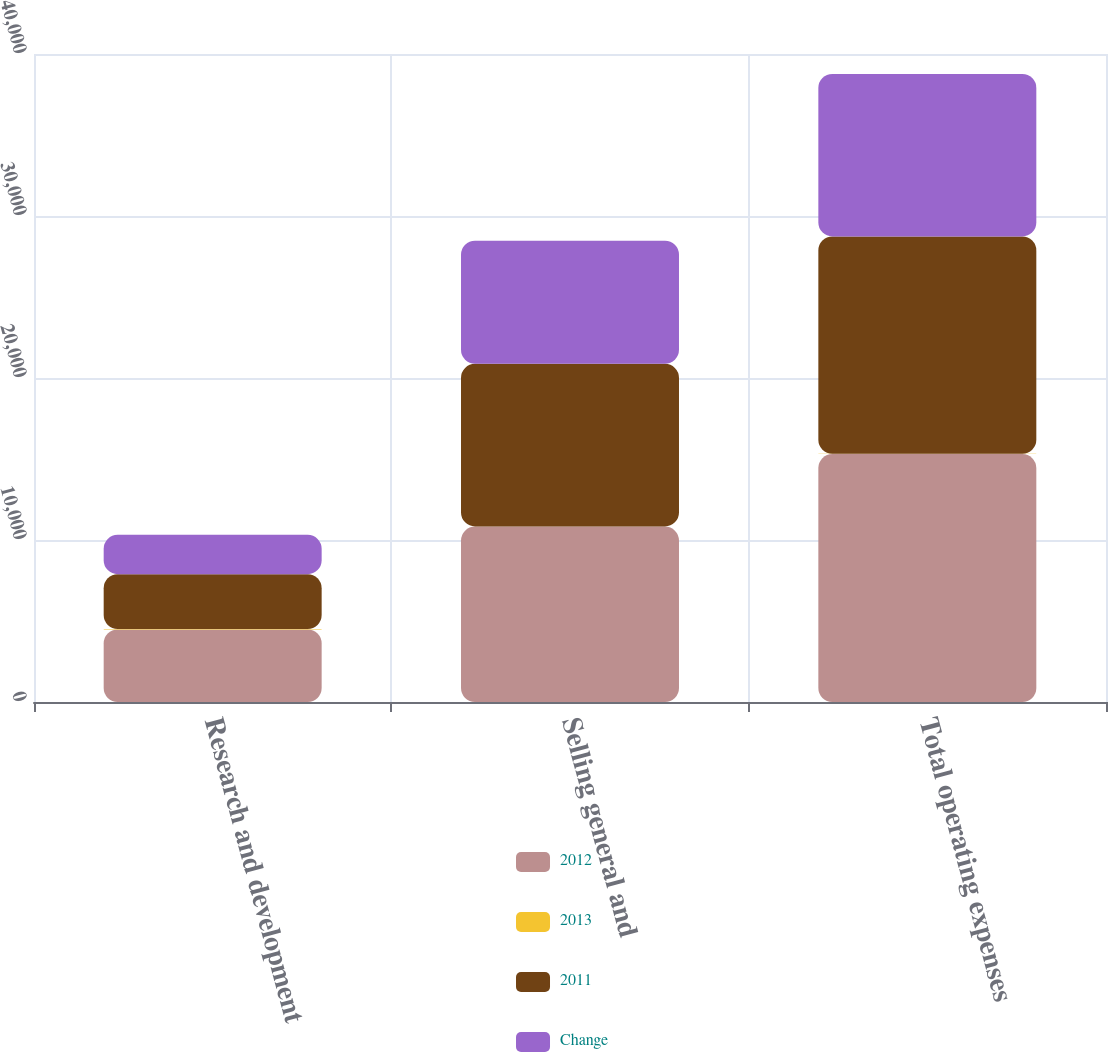Convert chart to OTSL. <chart><loc_0><loc_0><loc_500><loc_500><stacked_bar_chart><ecel><fcel>Research and development<fcel>Selling general and<fcel>Total operating expenses<nl><fcel>2012<fcel>4475<fcel>10830<fcel>15305<nl><fcel>2013<fcel>32<fcel>8<fcel>14<nl><fcel>2011<fcel>3381<fcel>10040<fcel>13421<nl><fcel>Change<fcel>2429<fcel>7599<fcel>10028<nl></chart> 